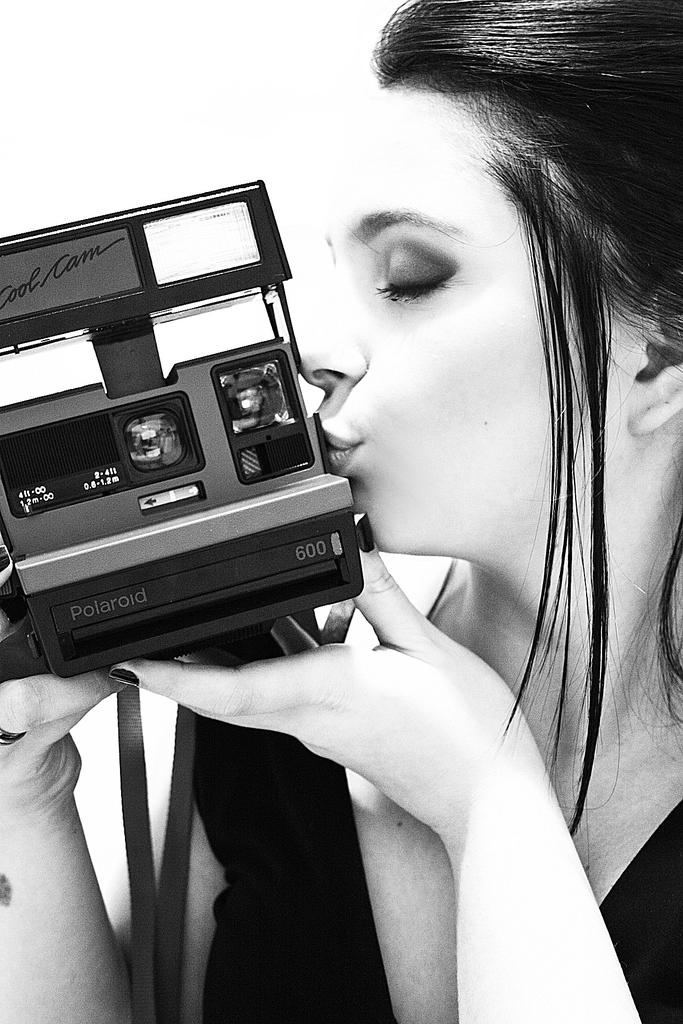Who is the main subject in the image? There is a woman in the image. What is the woman holding in the image? The woman is holding a camera. What is the woman doing in the image? The woman is kissing. What type of mountain can be seen in the background of the image? There is no mountain visible in the image; it only features a woman holding a camera and kissing. 